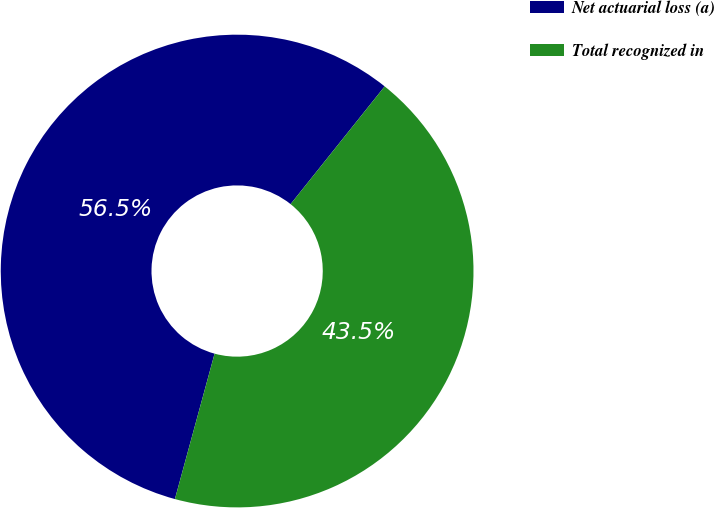Convert chart. <chart><loc_0><loc_0><loc_500><loc_500><pie_chart><fcel>Net actuarial loss (a)<fcel>Total recognized in<nl><fcel>56.49%<fcel>43.51%<nl></chart> 